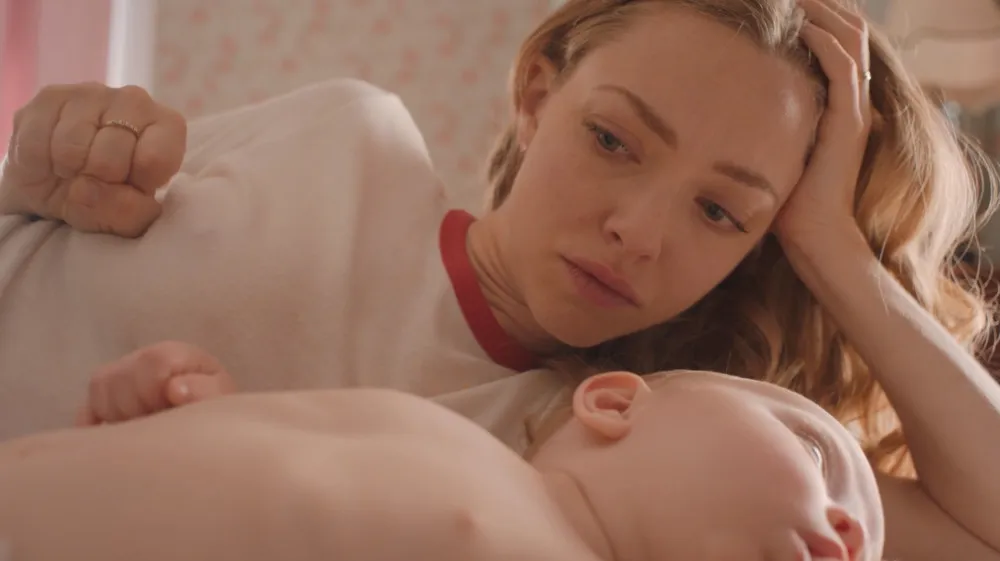Describe the possible relationship between the woman and the child. The physical closeness and the protective, gentle way the woman lies next to the baby suggest a maternal relationship. Her contemplative demeanor paired with her care in ensuring the baby’s comfort speaks to a deep, nurturing bond, typically seen between a mother and her child. 